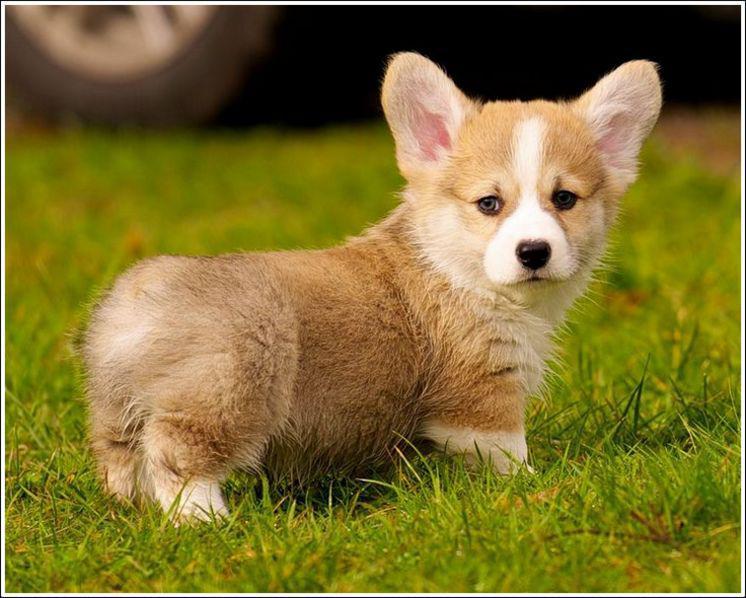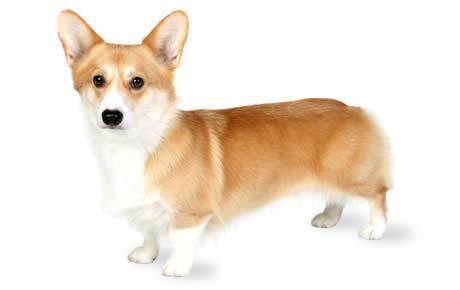The first image is the image on the left, the second image is the image on the right. For the images shown, is this caption "There are two dogs facing each other." true? Answer yes or no. Yes. The first image is the image on the left, the second image is the image on the right. For the images shown, is this caption "Both images show short-legged dogs standing on grass." true? Answer yes or no. No. The first image is the image on the left, the second image is the image on the right. Evaluate the accuracy of this statement regarding the images: "The bodies of the dogs in the two images turn toward each other.". Is it true? Answer yes or no. Yes. The first image is the image on the left, the second image is the image on the right. Analyze the images presented: Is the assertion "The images show a total of two short-legged dogs facing in opposite directions." valid? Answer yes or no. Yes. 